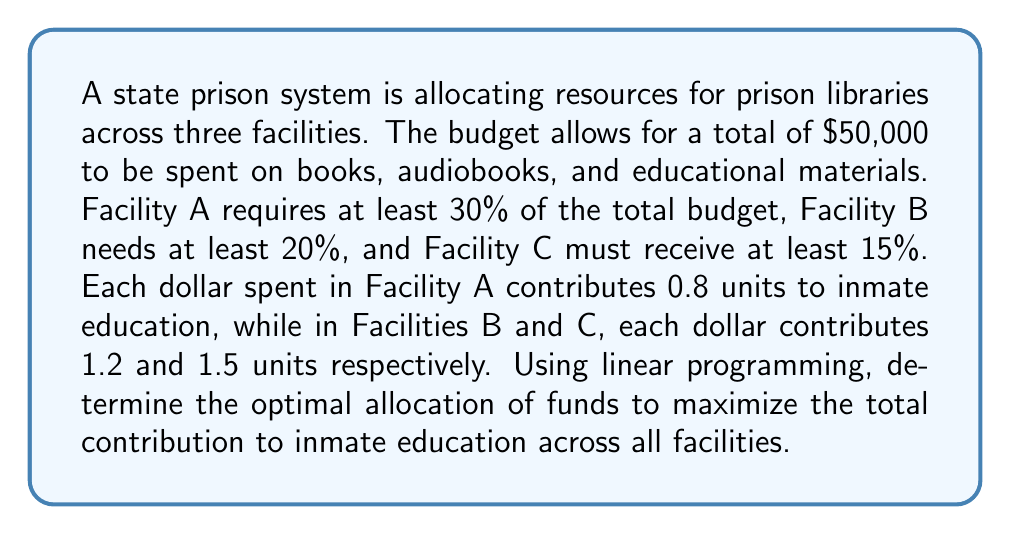Teach me how to tackle this problem. Let's approach this step-by-step using linear programming:

1. Define variables:
   $x_A$: amount allocated to Facility A
   $x_B$: amount allocated to Facility B
   $x_C$: amount allocated to Facility C

2. Objective function (to maximize):
   $$Z = 0.8x_A + 1.2x_B + 1.5x_C$$

3. Constraints:
   Total budget: $x_A + x_B + x_C \leq 50000$
   Facility A minimum: $x_A \geq 0.3(50000) = 15000$
   Facility B minimum: $x_B \geq 0.2(50000) = 10000$
   Facility C minimum: $x_C \geq 0.15(50000) = 7500$
   Non-negativity: $x_A, x_B, x_C \geq 0$

4. Set up the linear programming problem:
   Maximize: $Z = 0.8x_A + 1.2x_B + 1.5x_C$
   Subject to:
   $x_A + x_B + x_C \leq 50000$
   $x_A \geq 15000$
   $x_B \geq 10000$
   $x_C \geq 7500$
   $x_A, x_B, x_C \geq 0$

5. Solve using the simplex method or linear programming software:
   The optimal solution is:
   $x_A = 15000$ (minimum required)
   $x_B = 10000$ (minimum required)
   $x_C = 25000$ (remaining budget)

6. Calculate the maximum contribution to inmate education:
   $$Z = 0.8(15000) + 1.2(10000) + 1.5(25000) = 61500$$

Therefore, the optimal allocation is $15,000 to Facility A, $10,000 to Facility B, and $25,000 to Facility C, resulting in a total of 61,500 units of contribution to inmate education.
Answer: Facility A: $15,000; Facility B: $10,000; Facility C: $25,000; Max contribution: 61,500 units 